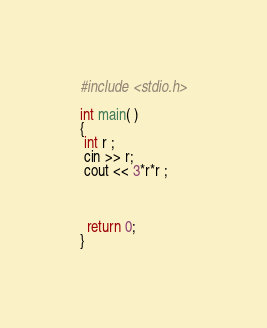<code> <loc_0><loc_0><loc_500><loc_500><_C++_>
#include <stdio.h>
 
int main( )
{
 int r ;
 cin >> r;
 cout << 3*r*r ;

 
 
  return 0;
}
</code> 